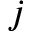<formula> <loc_0><loc_0><loc_500><loc_500>j</formula> 